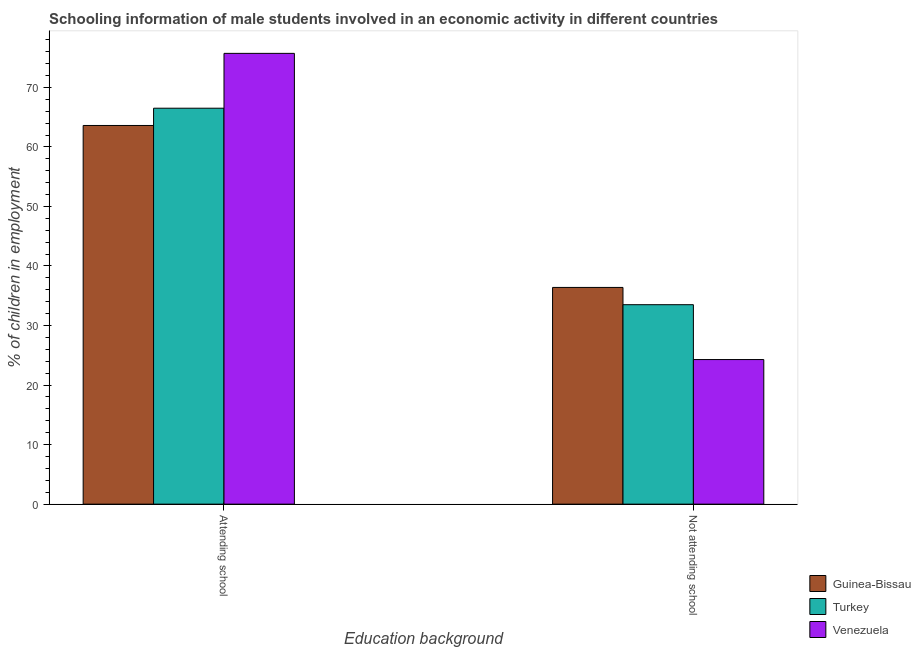How many different coloured bars are there?
Ensure brevity in your answer.  3. How many groups of bars are there?
Give a very brief answer. 2. Are the number of bars per tick equal to the number of legend labels?
Offer a very short reply. Yes. Are the number of bars on each tick of the X-axis equal?
Provide a succinct answer. Yes. How many bars are there on the 1st tick from the left?
Make the answer very short. 3. What is the label of the 1st group of bars from the left?
Your response must be concise. Attending school. What is the percentage of employed males who are not attending school in Guinea-Bissau?
Your response must be concise. 36.4. Across all countries, what is the maximum percentage of employed males who are not attending school?
Your response must be concise. 36.4. Across all countries, what is the minimum percentage of employed males who are not attending school?
Keep it short and to the point. 24.29. In which country was the percentage of employed males who are attending school maximum?
Your response must be concise. Venezuela. In which country was the percentage of employed males who are attending school minimum?
Your response must be concise. Guinea-Bissau. What is the total percentage of employed males who are attending school in the graph?
Offer a very short reply. 205.81. What is the difference between the percentage of employed males who are attending school in Turkey and that in Guinea-Bissau?
Ensure brevity in your answer.  2.9. What is the difference between the percentage of employed males who are attending school in Turkey and the percentage of employed males who are not attending school in Venezuela?
Your answer should be compact. 42.21. What is the average percentage of employed males who are not attending school per country?
Provide a short and direct response. 31.4. What is the difference between the percentage of employed males who are attending school and percentage of employed males who are not attending school in Guinea-Bissau?
Your answer should be compact. 27.2. In how many countries, is the percentage of employed males who are attending school greater than 76 %?
Your answer should be very brief. 0. What is the ratio of the percentage of employed males who are not attending school in Venezuela to that in Turkey?
Ensure brevity in your answer.  0.72. In how many countries, is the percentage of employed males who are attending school greater than the average percentage of employed males who are attending school taken over all countries?
Your answer should be very brief. 1. What does the 3rd bar from the left in Not attending school represents?
Offer a terse response. Venezuela. What does the 1st bar from the right in Not attending school represents?
Offer a terse response. Venezuela. What is the difference between two consecutive major ticks on the Y-axis?
Give a very brief answer. 10. Are the values on the major ticks of Y-axis written in scientific E-notation?
Give a very brief answer. No. Does the graph contain grids?
Your answer should be very brief. No. Where does the legend appear in the graph?
Ensure brevity in your answer.  Bottom right. How are the legend labels stacked?
Ensure brevity in your answer.  Vertical. What is the title of the graph?
Offer a very short reply. Schooling information of male students involved in an economic activity in different countries. Does "Upper middle income" appear as one of the legend labels in the graph?
Keep it short and to the point. No. What is the label or title of the X-axis?
Your response must be concise. Education background. What is the label or title of the Y-axis?
Ensure brevity in your answer.  % of children in employment. What is the % of children in employment of Guinea-Bissau in Attending school?
Your answer should be compact. 63.6. What is the % of children in employment of Turkey in Attending school?
Your answer should be very brief. 66.5. What is the % of children in employment in Venezuela in Attending school?
Provide a short and direct response. 75.71. What is the % of children in employment in Guinea-Bissau in Not attending school?
Provide a succinct answer. 36.4. What is the % of children in employment in Turkey in Not attending school?
Give a very brief answer. 33.5. What is the % of children in employment in Venezuela in Not attending school?
Make the answer very short. 24.29. Across all Education background, what is the maximum % of children in employment in Guinea-Bissau?
Give a very brief answer. 63.6. Across all Education background, what is the maximum % of children in employment in Turkey?
Provide a short and direct response. 66.5. Across all Education background, what is the maximum % of children in employment of Venezuela?
Keep it short and to the point. 75.71. Across all Education background, what is the minimum % of children in employment of Guinea-Bissau?
Your answer should be very brief. 36.4. Across all Education background, what is the minimum % of children in employment of Turkey?
Offer a terse response. 33.5. Across all Education background, what is the minimum % of children in employment of Venezuela?
Keep it short and to the point. 24.29. What is the total % of children in employment in Guinea-Bissau in the graph?
Offer a terse response. 100. What is the total % of children in employment of Turkey in the graph?
Offer a very short reply. 100. What is the total % of children in employment of Venezuela in the graph?
Give a very brief answer. 100. What is the difference between the % of children in employment in Guinea-Bissau in Attending school and that in Not attending school?
Keep it short and to the point. 27.2. What is the difference between the % of children in employment in Venezuela in Attending school and that in Not attending school?
Provide a succinct answer. 51.43. What is the difference between the % of children in employment of Guinea-Bissau in Attending school and the % of children in employment of Turkey in Not attending school?
Offer a very short reply. 30.1. What is the difference between the % of children in employment of Guinea-Bissau in Attending school and the % of children in employment of Venezuela in Not attending school?
Provide a short and direct response. 39.31. What is the difference between the % of children in employment in Turkey in Attending school and the % of children in employment in Venezuela in Not attending school?
Keep it short and to the point. 42.21. What is the average % of children in employment of Guinea-Bissau per Education background?
Your answer should be compact. 50. What is the average % of children in employment in Venezuela per Education background?
Keep it short and to the point. 50. What is the difference between the % of children in employment in Guinea-Bissau and % of children in employment in Turkey in Attending school?
Your response must be concise. -2.9. What is the difference between the % of children in employment of Guinea-Bissau and % of children in employment of Venezuela in Attending school?
Make the answer very short. -12.11. What is the difference between the % of children in employment in Turkey and % of children in employment in Venezuela in Attending school?
Keep it short and to the point. -9.21. What is the difference between the % of children in employment of Guinea-Bissau and % of children in employment of Venezuela in Not attending school?
Ensure brevity in your answer.  12.11. What is the difference between the % of children in employment in Turkey and % of children in employment in Venezuela in Not attending school?
Keep it short and to the point. 9.21. What is the ratio of the % of children in employment of Guinea-Bissau in Attending school to that in Not attending school?
Your response must be concise. 1.75. What is the ratio of the % of children in employment of Turkey in Attending school to that in Not attending school?
Give a very brief answer. 1.99. What is the ratio of the % of children in employment in Venezuela in Attending school to that in Not attending school?
Offer a very short reply. 3.12. What is the difference between the highest and the second highest % of children in employment in Guinea-Bissau?
Offer a terse response. 27.2. What is the difference between the highest and the second highest % of children in employment of Venezuela?
Offer a terse response. 51.43. What is the difference between the highest and the lowest % of children in employment in Guinea-Bissau?
Your response must be concise. 27.2. What is the difference between the highest and the lowest % of children in employment in Turkey?
Keep it short and to the point. 33. What is the difference between the highest and the lowest % of children in employment of Venezuela?
Provide a succinct answer. 51.43. 